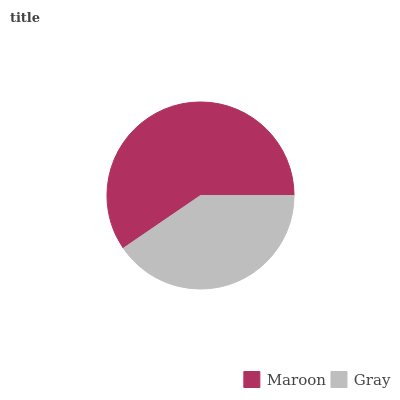Is Gray the minimum?
Answer yes or no. Yes. Is Maroon the maximum?
Answer yes or no. Yes. Is Gray the maximum?
Answer yes or no. No. Is Maroon greater than Gray?
Answer yes or no. Yes. Is Gray less than Maroon?
Answer yes or no. Yes. Is Gray greater than Maroon?
Answer yes or no. No. Is Maroon less than Gray?
Answer yes or no. No. Is Maroon the high median?
Answer yes or no. Yes. Is Gray the low median?
Answer yes or no. Yes. Is Gray the high median?
Answer yes or no. No. Is Maroon the low median?
Answer yes or no. No. 